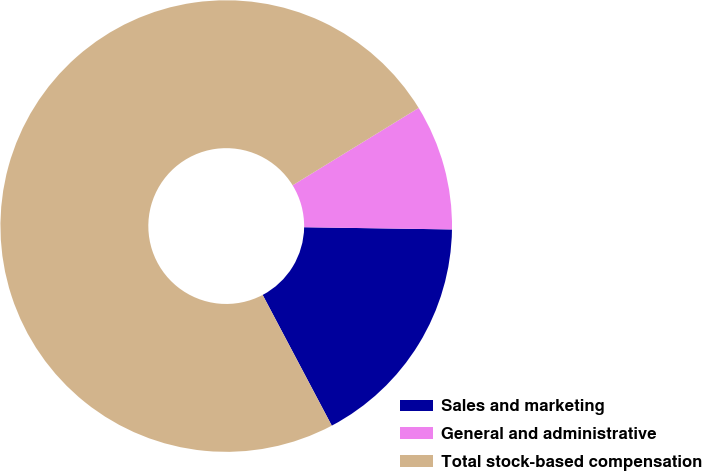<chart> <loc_0><loc_0><loc_500><loc_500><pie_chart><fcel>Sales and marketing<fcel>General and administrative<fcel>Total stock-based compensation<nl><fcel>17.02%<fcel>9.0%<fcel>73.98%<nl></chart> 